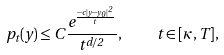<formula> <loc_0><loc_0><loc_500><loc_500>p _ { t } ( y ) \leq C \frac { e ^ { \frac { - c | y - y _ { 0 } | ^ { 2 } } { t } } } { t ^ { d / 2 } } , \quad t \in [ \kappa , T ] ,</formula> 